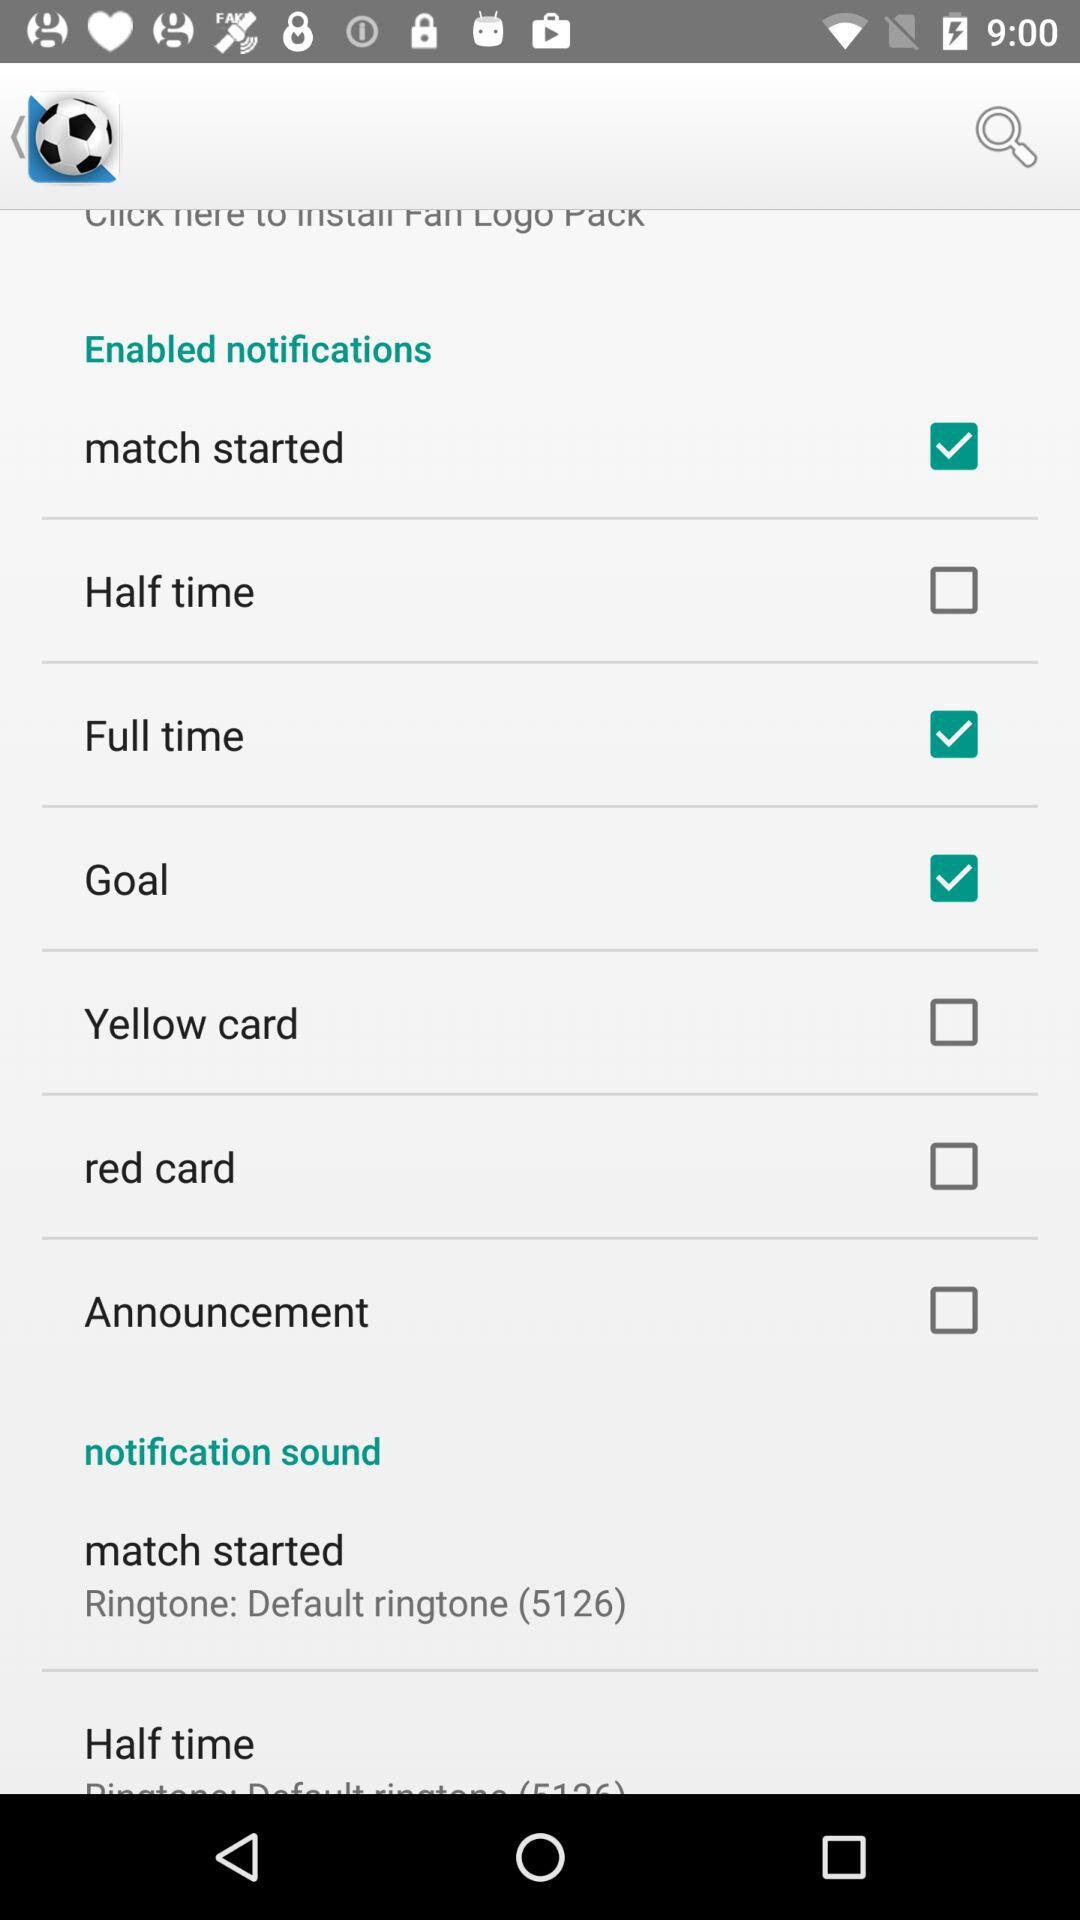Which notifications are enabled? The enabled notifications are "match started", "Full time" and "Goal". 